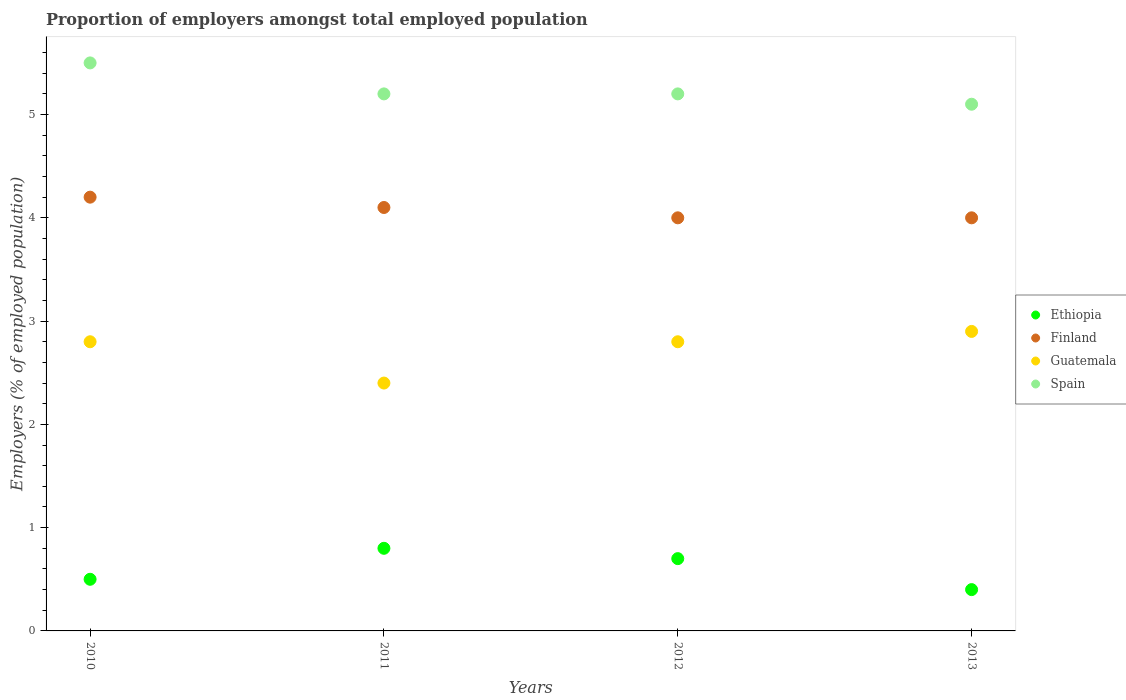Is the number of dotlines equal to the number of legend labels?
Give a very brief answer. Yes. What is the proportion of employers in Finland in 2011?
Offer a very short reply. 4.1. Across all years, what is the maximum proportion of employers in Guatemala?
Your answer should be compact. 2.9. Across all years, what is the minimum proportion of employers in Guatemala?
Ensure brevity in your answer.  2.4. In which year was the proportion of employers in Ethiopia maximum?
Provide a short and direct response. 2011. In which year was the proportion of employers in Finland minimum?
Provide a succinct answer. 2012. What is the total proportion of employers in Guatemala in the graph?
Offer a terse response. 10.9. What is the difference between the proportion of employers in Spain in 2011 and the proportion of employers in Guatemala in 2010?
Offer a terse response. 2.4. What is the average proportion of employers in Finland per year?
Give a very brief answer. 4.07. In the year 2011, what is the difference between the proportion of employers in Finland and proportion of employers in Guatemala?
Offer a very short reply. 1.7. In how many years, is the proportion of employers in Spain greater than 2 %?
Your answer should be compact. 4. What is the ratio of the proportion of employers in Spain in 2010 to that in 2012?
Your response must be concise. 1.06. Is the difference between the proportion of employers in Finland in 2011 and 2012 greater than the difference between the proportion of employers in Guatemala in 2011 and 2012?
Give a very brief answer. Yes. What is the difference between the highest and the second highest proportion of employers in Spain?
Give a very brief answer. 0.3. What is the difference between the highest and the lowest proportion of employers in Guatemala?
Ensure brevity in your answer.  0.5. In how many years, is the proportion of employers in Finland greater than the average proportion of employers in Finland taken over all years?
Make the answer very short. 2. Is it the case that in every year, the sum of the proportion of employers in Guatemala and proportion of employers in Spain  is greater than the proportion of employers in Finland?
Give a very brief answer. Yes. Does the proportion of employers in Finland monotonically increase over the years?
Give a very brief answer. No. What is the difference between two consecutive major ticks on the Y-axis?
Your answer should be very brief. 1. Does the graph contain grids?
Provide a short and direct response. No. Where does the legend appear in the graph?
Offer a very short reply. Center right. How many legend labels are there?
Provide a succinct answer. 4. How are the legend labels stacked?
Give a very brief answer. Vertical. What is the title of the graph?
Make the answer very short. Proportion of employers amongst total employed population. Does "Ghana" appear as one of the legend labels in the graph?
Offer a terse response. No. What is the label or title of the X-axis?
Your response must be concise. Years. What is the label or title of the Y-axis?
Your response must be concise. Employers (% of employed population). What is the Employers (% of employed population) of Finland in 2010?
Your answer should be very brief. 4.2. What is the Employers (% of employed population) in Guatemala in 2010?
Ensure brevity in your answer.  2.8. What is the Employers (% of employed population) in Ethiopia in 2011?
Your answer should be very brief. 0.8. What is the Employers (% of employed population) in Finland in 2011?
Give a very brief answer. 4.1. What is the Employers (% of employed population) of Guatemala in 2011?
Your answer should be compact. 2.4. What is the Employers (% of employed population) of Spain in 2011?
Your answer should be very brief. 5.2. What is the Employers (% of employed population) of Ethiopia in 2012?
Your answer should be very brief. 0.7. What is the Employers (% of employed population) in Finland in 2012?
Your response must be concise. 4. What is the Employers (% of employed population) of Guatemala in 2012?
Keep it short and to the point. 2.8. What is the Employers (% of employed population) in Spain in 2012?
Your answer should be very brief. 5.2. What is the Employers (% of employed population) of Ethiopia in 2013?
Provide a succinct answer. 0.4. What is the Employers (% of employed population) in Guatemala in 2013?
Offer a terse response. 2.9. What is the Employers (% of employed population) in Spain in 2013?
Ensure brevity in your answer.  5.1. Across all years, what is the maximum Employers (% of employed population) in Ethiopia?
Make the answer very short. 0.8. Across all years, what is the maximum Employers (% of employed population) in Finland?
Your answer should be very brief. 4.2. Across all years, what is the maximum Employers (% of employed population) of Guatemala?
Provide a succinct answer. 2.9. Across all years, what is the maximum Employers (% of employed population) in Spain?
Your response must be concise. 5.5. Across all years, what is the minimum Employers (% of employed population) in Ethiopia?
Provide a short and direct response. 0.4. Across all years, what is the minimum Employers (% of employed population) in Guatemala?
Your answer should be very brief. 2.4. Across all years, what is the minimum Employers (% of employed population) of Spain?
Ensure brevity in your answer.  5.1. What is the total Employers (% of employed population) in Ethiopia in the graph?
Keep it short and to the point. 2.4. What is the total Employers (% of employed population) of Spain in the graph?
Your answer should be very brief. 21. What is the difference between the Employers (% of employed population) of Guatemala in 2010 and that in 2011?
Keep it short and to the point. 0.4. What is the difference between the Employers (% of employed population) of Spain in 2010 and that in 2011?
Your answer should be very brief. 0.3. What is the difference between the Employers (% of employed population) in Ethiopia in 2010 and that in 2012?
Your response must be concise. -0.2. What is the difference between the Employers (% of employed population) in Finland in 2010 and that in 2012?
Give a very brief answer. 0.2. What is the difference between the Employers (% of employed population) of Guatemala in 2010 and that in 2013?
Offer a very short reply. -0.1. What is the difference between the Employers (% of employed population) of Ethiopia in 2011 and that in 2012?
Offer a very short reply. 0.1. What is the difference between the Employers (% of employed population) in Finland in 2011 and that in 2012?
Your answer should be compact. 0.1. What is the difference between the Employers (% of employed population) in Guatemala in 2011 and that in 2012?
Your answer should be compact. -0.4. What is the difference between the Employers (% of employed population) of Spain in 2011 and that in 2012?
Keep it short and to the point. 0. What is the difference between the Employers (% of employed population) in Finland in 2011 and that in 2013?
Your answer should be compact. 0.1. What is the difference between the Employers (% of employed population) of Guatemala in 2011 and that in 2013?
Your answer should be very brief. -0.5. What is the difference between the Employers (% of employed population) in Guatemala in 2012 and that in 2013?
Offer a very short reply. -0.1. What is the difference between the Employers (% of employed population) of Spain in 2012 and that in 2013?
Give a very brief answer. 0.1. What is the difference between the Employers (% of employed population) of Ethiopia in 2010 and the Employers (% of employed population) of Finland in 2011?
Keep it short and to the point. -3.6. What is the difference between the Employers (% of employed population) in Ethiopia in 2010 and the Employers (% of employed population) in Guatemala in 2011?
Give a very brief answer. -1.9. What is the difference between the Employers (% of employed population) of Ethiopia in 2010 and the Employers (% of employed population) of Spain in 2011?
Your answer should be compact. -4.7. What is the difference between the Employers (% of employed population) of Finland in 2010 and the Employers (% of employed population) of Guatemala in 2011?
Your answer should be very brief. 1.8. What is the difference between the Employers (% of employed population) of Guatemala in 2010 and the Employers (% of employed population) of Spain in 2011?
Provide a short and direct response. -2.4. What is the difference between the Employers (% of employed population) in Ethiopia in 2010 and the Employers (% of employed population) in Guatemala in 2012?
Your response must be concise. -2.3. What is the difference between the Employers (% of employed population) of Ethiopia in 2010 and the Employers (% of employed population) of Finland in 2013?
Make the answer very short. -3.5. What is the difference between the Employers (% of employed population) of Ethiopia in 2010 and the Employers (% of employed population) of Guatemala in 2013?
Offer a very short reply. -2.4. What is the difference between the Employers (% of employed population) of Ethiopia in 2010 and the Employers (% of employed population) of Spain in 2013?
Provide a succinct answer. -4.6. What is the difference between the Employers (% of employed population) of Finland in 2010 and the Employers (% of employed population) of Guatemala in 2013?
Your answer should be compact. 1.3. What is the difference between the Employers (% of employed population) in Finland in 2010 and the Employers (% of employed population) in Spain in 2013?
Keep it short and to the point. -0.9. What is the difference between the Employers (% of employed population) of Finland in 2011 and the Employers (% of employed population) of Guatemala in 2012?
Give a very brief answer. 1.3. What is the difference between the Employers (% of employed population) of Ethiopia in 2011 and the Employers (% of employed population) of Finland in 2013?
Make the answer very short. -3.2. What is the difference between the Employers (% of employed population) of Finland in 2011 and the Employers (% of employed population) of Guatemala in 2013?
Ensure brevity in your answer.  1.2. What is the difference between the Employers (% of employed population) in Finland in 2011 and the Employers (% of employed population) in Spain in 2013?
Your answer should be very brief. -1. What is the difference between the Employers (% of employed population) of Guatemala in 2011 and the Employers (% of employed population) of Spain in 2013?
Your answer should be compact. -2.7. What is the difference between the Employers (% of employed population) in Ethiopia in 2012 and the Employers (% of employed population) in Guatemala in 2013?
Provide a succinct answer. -2.2. What is the difference between the Employers (% of employed population) of Ethiopia in 2012 and the Employers (% of employed population) of Spain in 2013?
Offer a terse response. -4.4. What is the difference between the Employers (% of employed population) of Finland in 2012 and the Employers (% of employed population) of Guatemala in 2013?
Give a very brief answer. 1.1. What is the average Employers (% of employed population) in Finland per year?
Make the answer very short. 4.08. What is the average Employers (% of employed population) of Guatemala per year?
Offer a terse response. 2.73. What is the average Employers (% of employed population) in Spain per year?
Ensure brevity in your answer.  5.25. In the year 2010, what is the difference between the Employers (% of employed population) of Ethiopia and Employers (% of employed population) of Finland?
Keep it short and to the point. -3.7. In the year 2010, what is the difference between the Employers (% of employed population) of Ethiopia and Employers (% of employed population) of Guatemala?
Offer a very short reply. -2.3. In the year 2010, what is the difference between the Employers (% of employed population) in Finland and Employers (% of employed population) in Spain?
Your response must be concise. -1.3. In the year 2011, what is the difference between the Employers (% of employed population) of Ethiopia and Employers (% of employed population) of Finland?
Your answer should be very brief. -3.3. In the year 2011, what is the difference between the Employers (% of employed population) in Ethiopia and Employers (% of employed population) in Guatemala?
Give a very brief answer. -1.6. In the year 2011, what is the difference between the Employers (% of employed population) of Ethiopia and Employers (% of employed population) of Spain?
Provide a succinct answer. -4.4. In the year 2012, what is the difference between the Employers (% of employed population) in Ethiopia and Employers (% of employed population) in Guatemala?
Make the answer very short. -2.1. In the year 2012, what is the difference between the Employers (% of employed population) of Ethiopia and Employers (% of employed population) of Spain?
Your answer should be very brief. -4.5. In the year 2012, what is the difference between the Employers (% of employed population) in Finland and Employers (% of employed population) in Guatemala?
Ensure brevity in your answer.  1.2. In the year 2012, what is the difference between the Employers (% of employed population) of Guatemala and Employers (% of employed population) of Spain?
Offer a terse response. -2.4. In the year 2013, what is the difference between the Employers (% of employed population) in Ethiopia and Employers (% of employed population) in Guatemala?
Offer a very short reply. -2.5. In the year 2013, what is the difference between the Employers (% of employed population) in Finland and Employers (% of employed population) in Spain?
Your answer should be very brief. -1.1. In the year 2013, what is the difference between the Employers (% of employed population) in Guatemala and Employers (% of employed population) in Spain?
Offer a very short reply. -2.2. What is the ratio of the Employers (% of employed population) in Ethiopia in 2010 to that in 2011?
Provide a short and direct response. 0.62. What is the ratio of the Employers (% of employed population) of Finland in 2010 to that in 2011?
Offer a terse response. 1.02. What is the ratio of the Employers (% of employed population) of Guatemala in 2010 to that in 2011?
Provide a succinct answer. 1.17. What is the ratio of the Employers (% of employed population) of Spain in 2010 to that in 2011?
Keep it short and to the point. 1.06. What is the ratio of the Employers (% of employed population) in Finland in 2010 to that in 2012?
Your answer should be compact. 1.05. What is the ratio of the Employers (% of employed population) in Spain in 2010 to that in 2012?
Offer a very short reply. 1.06. What is the ratio of the Employers (% of employed population) of Ethiopia in 2010 to that in 2013?
Keep it short and to the point. 1.25. What is the ratio of the Employers (% of employed population) in Guatemala in 2010 to that in 2013?
Offer a very short reply. 0.97. What is the ratio of the Employers (% of employed population) in Spain in 2010 to that in 2013?
Make the answer very short. 1.08. What is the ratio of the Employers (% of employed population) in Ethiopia in 2011 to that in 2012?
Your answer should be compact. 1.14. What is the ratio of the Employers (% of employed population) of Guatemala in 2011 to that in 2012?
Offer a very short reply. 0.86. What is the ratio of the Employers (% of employed population) of Finland in 2011 to that in 2013?
Your answer should be compact. 1.02. What is the ratio of the Employers (% of employed population) of Guatemala in 2011 to that in 2013?
Offer a terse response. 0.83. What is the ratio of the Employers (% of employed population) of Spain in 2011 to that in 2013?
Make the answer very short. 1.02. What is the ratio of the Employers (% of employed population) in Ethiopia in 2012 to that in 2013?
Your response must be concise. 1.75. What is the ratio of the Employers (% of employed population) in Finland in 2012 to that in 2013?
Make the answer very short. 1. What is the ratio of the Employers (% of employed population) in Guatemala in 2012 to that in 2013?
Give a very brief answer. 0.97. What is the ratio of the Employers (% of employed population) in Spain in 2012 to that in 2013?
Provide a succinct answer. 1.02. What is the difference between the highest and the second highest Employers (% of employed population) in Ethiopia?
Ensure brevity in your answer.  0.1. What is the difference between the highest and the second highest Employers (% of employed population) of Finland?
Your response must be concise. 0.1. What is the difference between the highest and the second highest Employers (% of employed population) in Spain?
Make the answer very short. 0.3. 